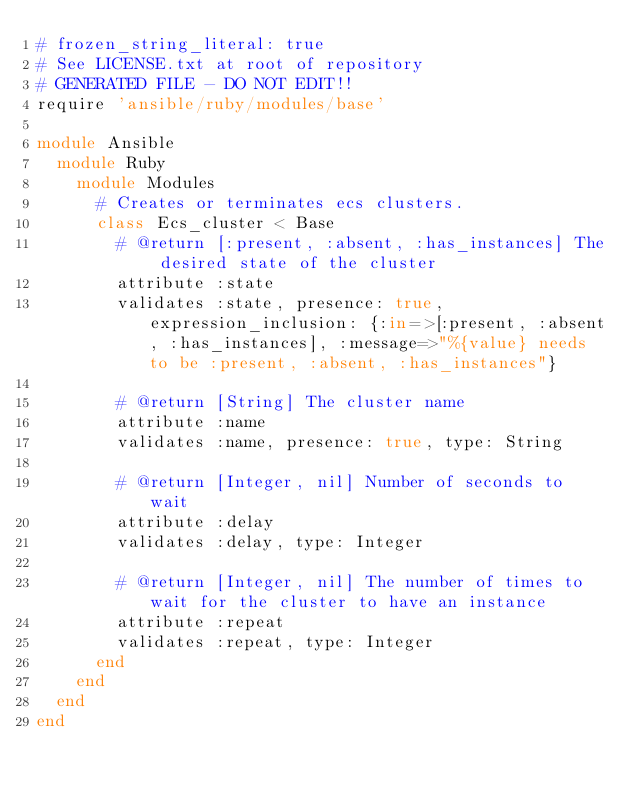<code> <loc_0><loc_0><loc_500><loc_500><_Ruby_># frozen_string_literal: true
# See LICENSE.txt at root of repository
# GENERATED FILE - DO NOT EDIT!!
require 'ansible/ruby/modules/base'

module Ansible
  module Ruby
    module Modules
      # Creates or terminates ecs clusters.
      class Ecs_cluster < Base
        # @return [:present, :absent, :has_instances] The desired state of the cluster
        attribute :state
        validates :state, presence: true, expression_inclusion: {:in=>[:present, :absent, :has_instances], :message=>"%{value} needs to be :present, :absent, :has_instances"}

        # @return [String] The cluster name
        attribute :name
        validates :name, presence: true, type: String

        # @return [Integer, nil] Number of seconds to wait
        attribute :delay
        validates :delay, type: Integer

        # @return [Integer, nil] The number of times to wait for the cluster to have an instance
        attribute :repeat
        validates :repeat, type: Integer
      end
    end
  end
end
</code> 